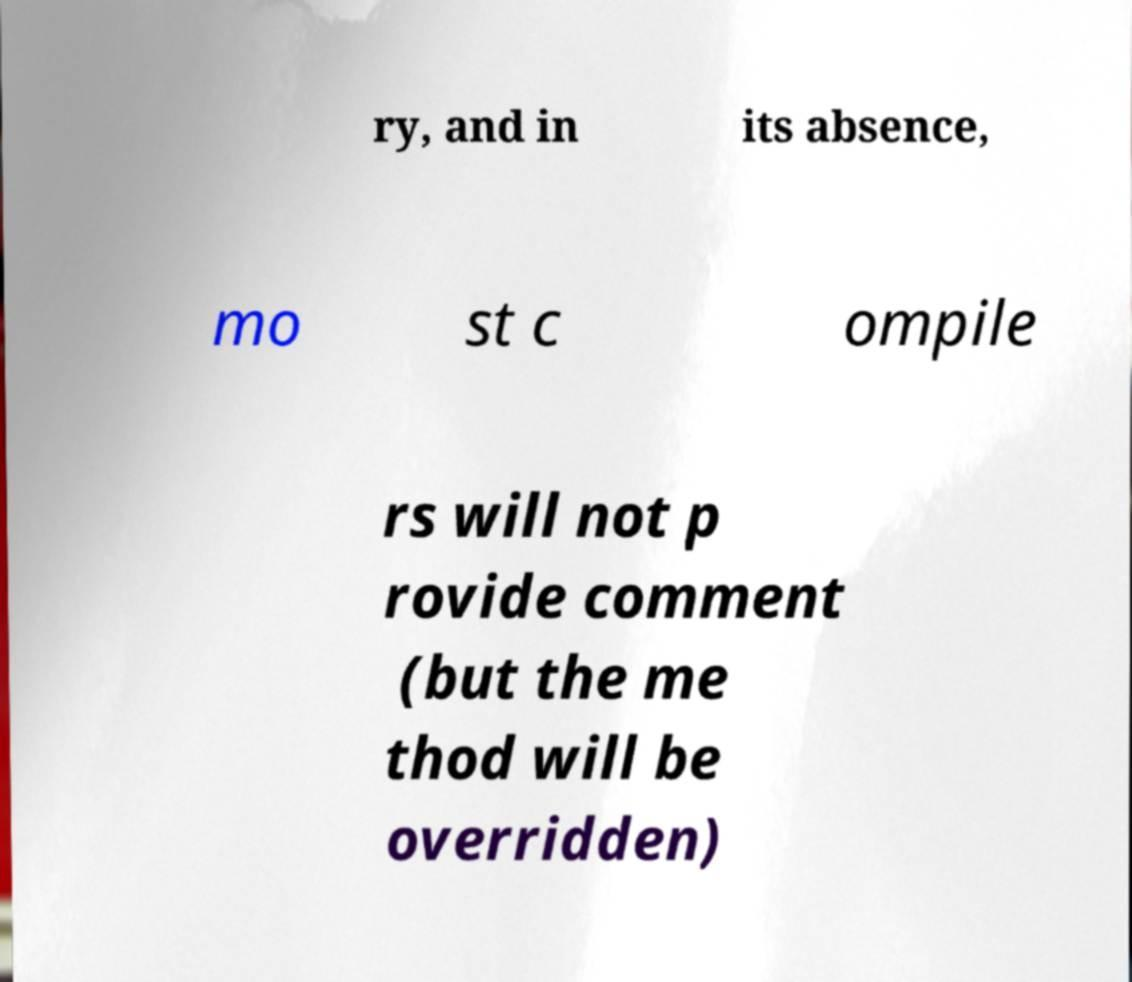I need the written content from this picture converted into text. Can you do that? ry, and in its absence, mo st c ompile rs will not p rovide comment (but the me thod will be overridden) 